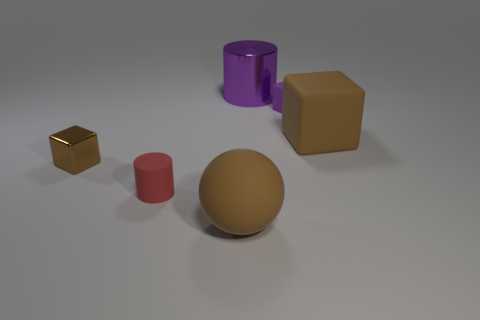Subtract all tiny blocks. How many blocks are left? 1 Add 3 big cyan things. How many objects exist? 9 Subtract all cylinders. How many objects are left? 4 Subtract all yellow cylinders. How many brown cubes are left? 2 Subtract all purple cubes. How many cubes are left? 2 Add 5 large cubes. How many large cubes are left? 6 Add 4 tiny red matte objects. How many tiny red matte objects exist? 5 Subtract 1 purple cylinders. How many objects are left? 5 Subtract all gray cylinders. Subtract all green cubes. How many cylinders are left? 2 Subtract all small matte things. Subtract all brown matte balls. How many objects are left? 3 